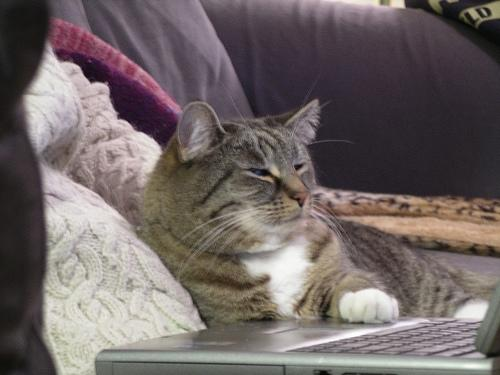What is similar to the long things on the animal's face? stripes 